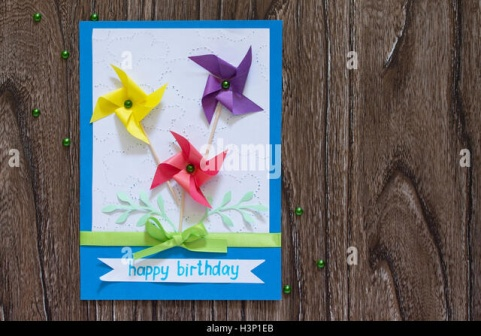What do the pinwheels on the card symbolize? The pinwheels on the card symbolize joy, celebration, and the playful spirit often associated with birthdays. Their vibrant colors and whimsical design add a touch of fun and happiness to the card, making it an ideal choice for marking such a joyful occasion. 